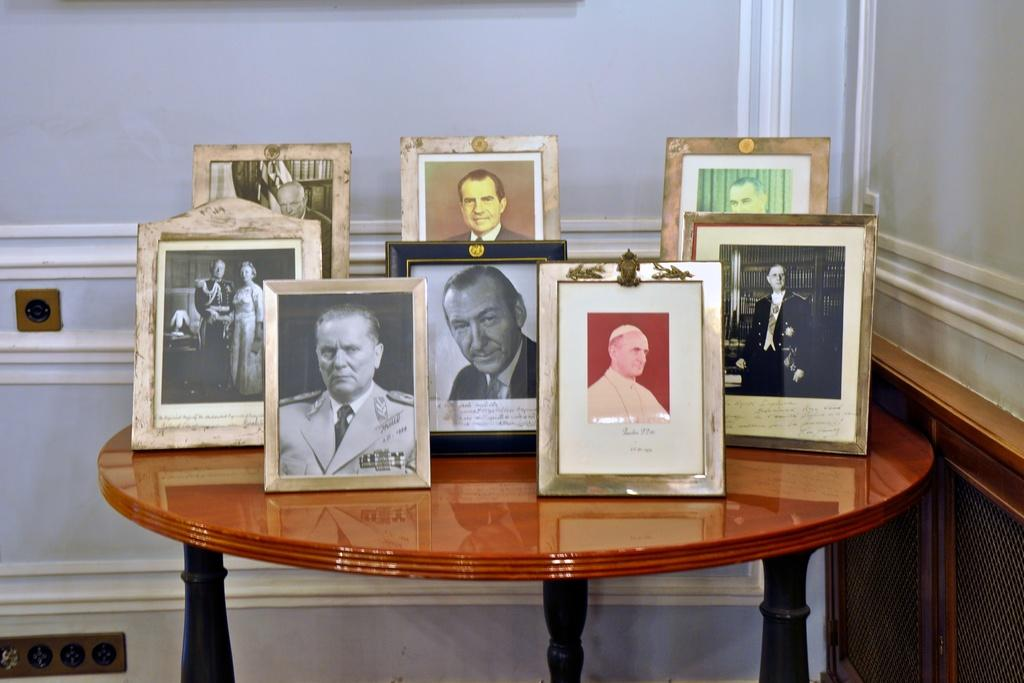Where is the setting of the image? The image is inside a room. What piece of furniture can be seen in the image? There is a table in the image. What objects are placed on the table? There are photo frames on the table. Where is the switch board located in the image? The switch board is on the left side of the table. What is on the right side of the table? There is a wall on the right side of the table. What type of teeth can be seen in the photo frames on the table? There are no teeth visible in the photo frames or anywhere else in the image. 